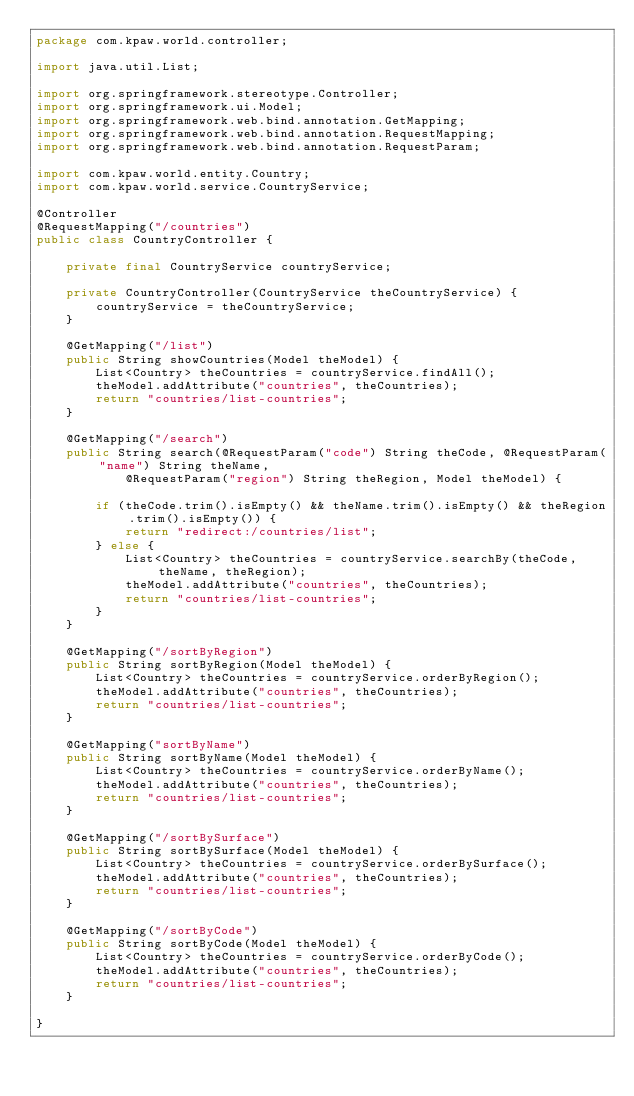<code> <loc_0><loc_0><loc_500><loc_500><_Java_>package com.kpaw.world.controller;

import java.util.List;

import org.springframework.stereotype.Controller;
import org.springframework.ui.Model;
import org.springframework.web.bind.annotation.GetMapping;
import org.springframework.web.bind.annotation.RequestMapping;
import org.springframework.web.bind.annotation.RequestParam;

import com.kpaw.world.entity.Country;
import com.kpaw.world.service.CountryService;

@Controller
@RequestMapping("/countries")
public class CountryController {

	private final CountryService countryService;

	private CountryController(CountryService theCountryService) {
		countryService = theCountryService;
	}

	@GetMapping("/list")
	public String showCountries(Model theModel) {
		List<Country> theCountries = countryService.findAll();
		theModel.addAttribute("countries", theCountries);
		return "countries/list-countries";
	}

	@GetMapping("/search")
	public String search(@RequestParam("code") String theCode, @RequestParam("name") String theName,
			@RequestParam("region") String theRegion, Model theModel) {

		if (theCode.trim().isEmpty() && theName.trim().isEmpty() && theRegion.trim().isEmpty()) {
			return "redirect:/countries/list";
		} else {
			List<Country> theCountries = countryService.searchBy(theCode, theName, theRegion);
			theModel.addAttribute("countries", theCountries);
			return "countries/list-countries";
		}
	}

	@GetMapping("/sortByRegion")
	public String sortByRegion(Model theModel) {
		List<Country> theCountries = countryService.orderByRegion();
		theModel.addAttribute("countries", theCountries);
		return "countries/list-countries";
	}

	@GetMapping("sortByName")
	public String sortByName(Model theModel) {
		List<Country> theCountries = countryService.orderByName();
		theModel.addAttribute("countries", theCountries);
		return "countries/list-countries";
	}

	@GetMapping("/sortBySurface")
	public String sortBySurface(Model theModel) {
		List<Country> theCountries = countryService.orderBySurface();
		theModel.addAttribute("countries", theCountries);
		return "countries/list-countries";
	}

	@GetMapping("/sortByCode")
	public String sortByCode(Model theModel) {
		List<Country> theCountries = countryService.orderByCode();
		theModel.addAttribute("countries", theCountries);
		return "countries/list-countries";
	}

}
</code> 